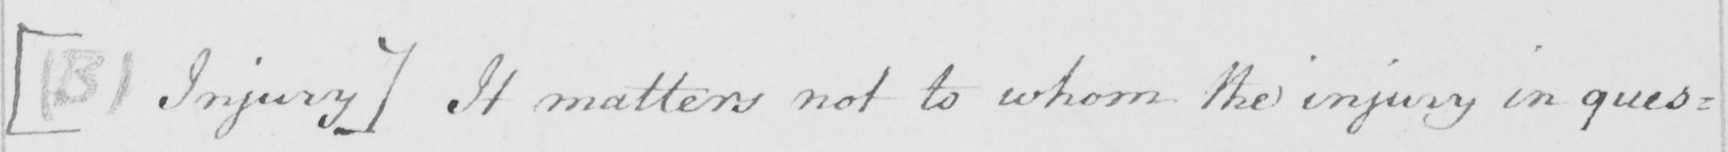Can you read and transcribe this handwriting? [(B1 Injury] It matters not to whom the injury in ques= 